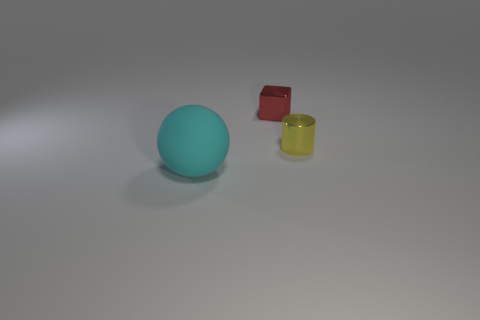How do the objects in this image relate to each other? The objects seem to be intentionally arranged to demonstrate a variety of shapes and colors, possibly for educational or artistic purposes. They are spaced apart on a flat surface, allowing each object to be distinctly observed without overlapping. 